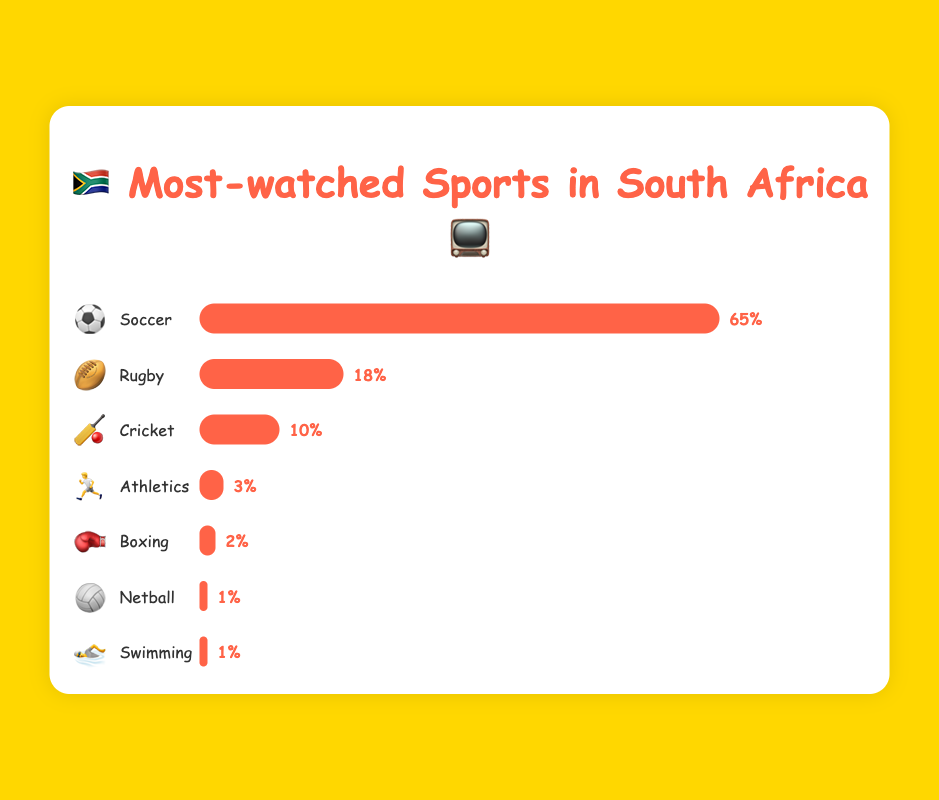Which sport has the highest viewership percentage? The sport with the highest viewership percentage can be identified by the longest bar in the chart. Soccer has the longest bar with 65%.
Answer: Soccer ⚽ How much higher is soccer's viewership compared to rugby's? Soccer's viewership is 65%, and rugby's is 18%. The difference is calculated by subtracting rugby's viewership from soccer's: 65% - 18% = 47%.
Answer: 47% Which sport has the lowest viewership percentage? The sport with the shortest bar and lowest percentage value is Netball and Swimming, both with 1%.
Answer: Netball 🏐 and Swimming 🏊 What is the total percentage of viewership for Cricket and Athletics combined? Cricket's viewership is 10% and Athletics' viewership is 3%. Adding them together: 10% + 3% = 13%.
Answer: 13% Compare the viewership of Boxing to Athletics. By how much does Boxing differ from Athletics? Athletics has a viewership of 3%, and Boxing has 2%. The difference is 3% - 2% = 1%.
Answer: 1% What percentage of the total viewership is accounted for by sports other than Soccer? Soccer has 65% viewership. The total viewership for other sports is: 100% - 65% = 35%.
Answer: 35% Which sports have a viewership percentage equal to or less than 2%? From the chart, Boxing (2%), Netball (1%), and Swimming (1%) are the sports with 2% or less viewership.
Answer: Boxing 🥊, Netball 🏐, and Swimming 🏊 What is the average viewership percentage for Rugby and Cricket? Rugby has 18% viewership, and Cricket has 10%. The average is calculated by (18% + 10%) / 2 = 14%.
Answer: 14% How does the viewership of Athletics compare to that of Netball and Swimming combined? Athletics has 3% viewership. Netball and Swimming each have 1%, combined 1% + 1% = 2%. Athletics' viewership (3%) is 1% higher.
Answer: Athletics is 1% higher If you combine the viewership of Rugby, Cricket, and Athletics, what percentage do you get? Rugby (18%), Cricket (10%), and Athletics (3%) together: 18% + 10% + 3% = 31%.
Answer: 31% 